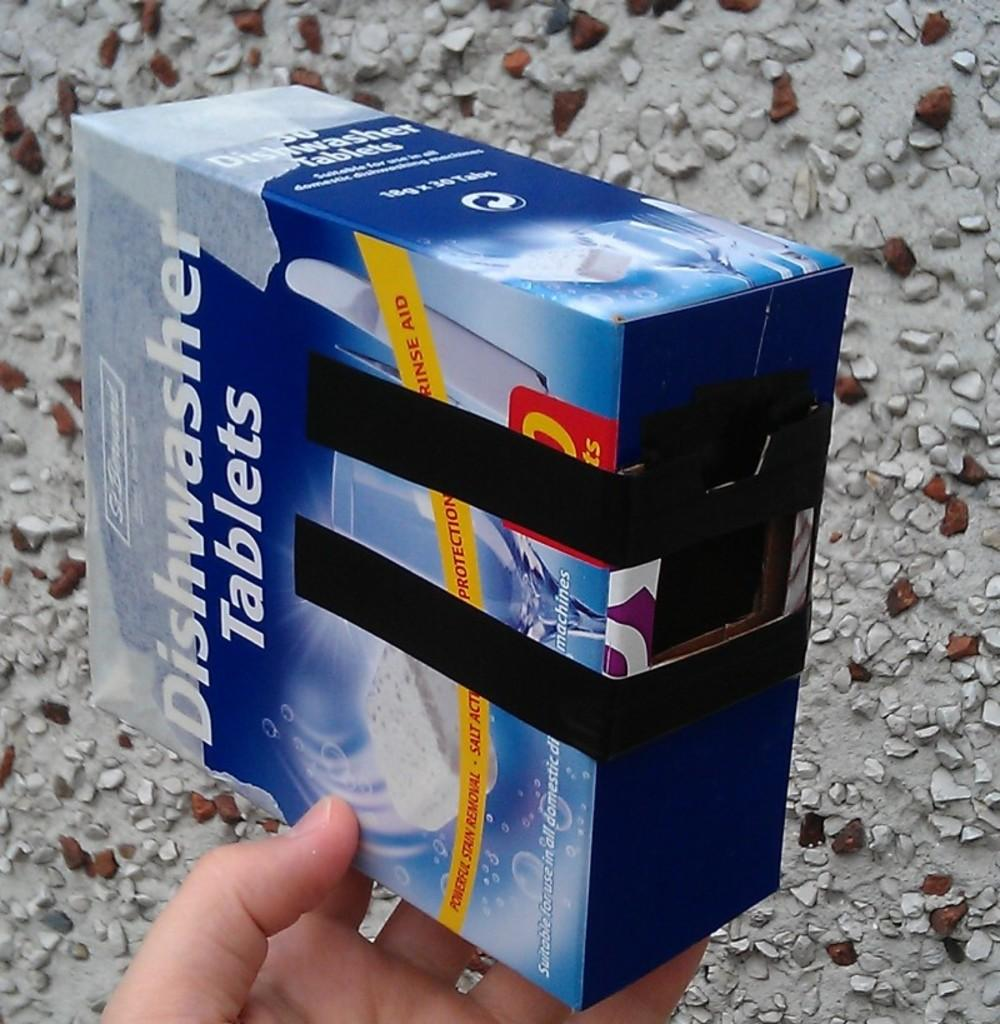<image>
Summarize the visual content of the image. A person holding a box of diswasher tablets. 